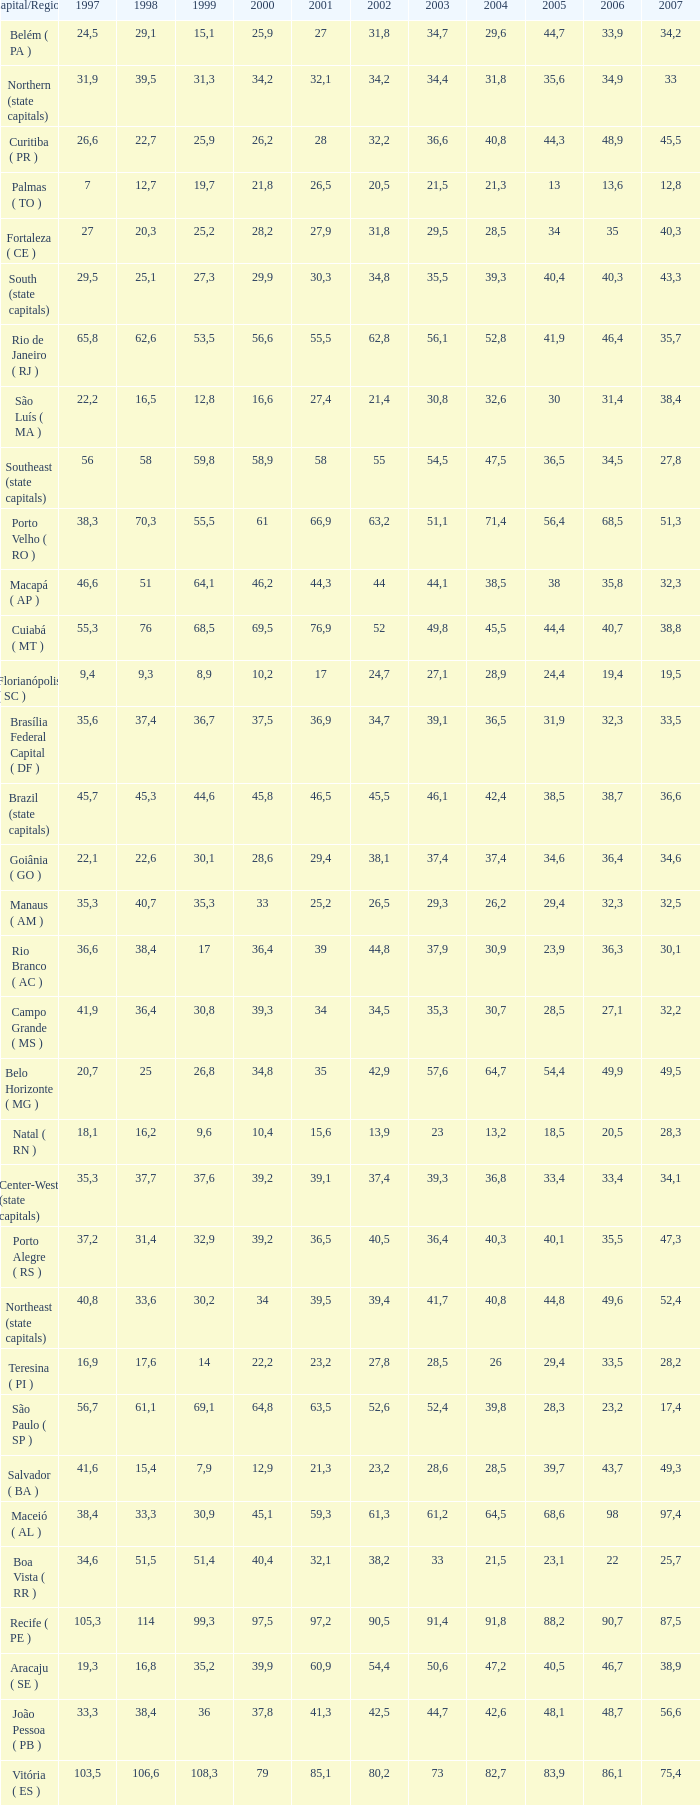What is the average 2000 that has a 1997 greater than 34,6, a 2006 greater than 38,7, and a 2998 less than 76? 41.92. 